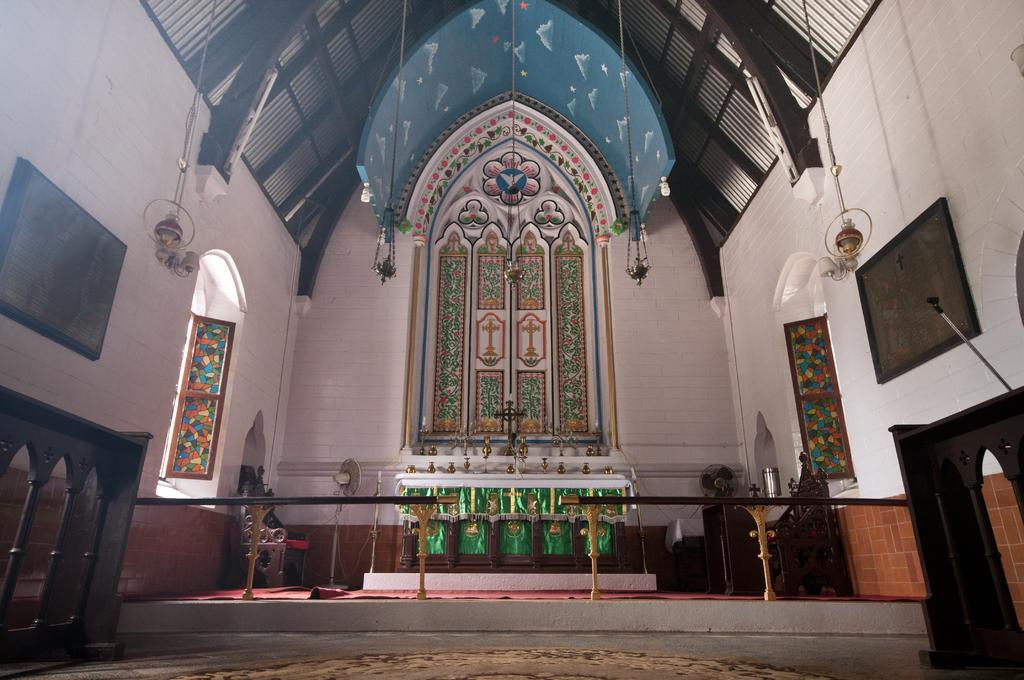Can you describe this image briefly? This is the inside view of a church and on the left side we can see a wooden fence. There are window doors, frames on the wall, objects hanging to the roof top, cross symbol, designs on the wall, cloth, table fans and other objects. 